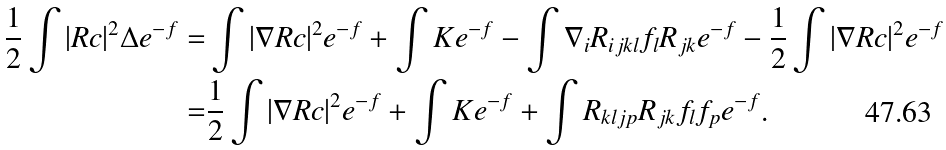Convert formula to latex. <formula><loc_0><loc_0><loc_500><loc_500>\frac { 1 } { 2 } \int | R c | ^ { 2 } \Delta e ^ { - f } = & \int | \nabla R c | ^ { 2 } e ^ { - f } + \int K e ^ { - f } - \int \nabla _ { i } R _ { i j k l } f _ { l } R _ { j k } e ^ { - f } - \frac { 1 } { 2 } \int | \nabla R c | ^ { 2 } e ^ { - f } \\ = & \frac { 1 } { 2 } \int | \nabla R c | ^ { 2 } e ^ { - f } + \int K e ^ { - f } + \int R _ { k l j p } R _ { j k } f _ { l } f _ { p } e ^ { - f } .</formula> 